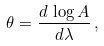Convert formula to latex. <formula><loc_0><loc_0><loc_500><loc_500>\theta = \frac { d \, \log A } { d \lambda } \, ,</formula> 